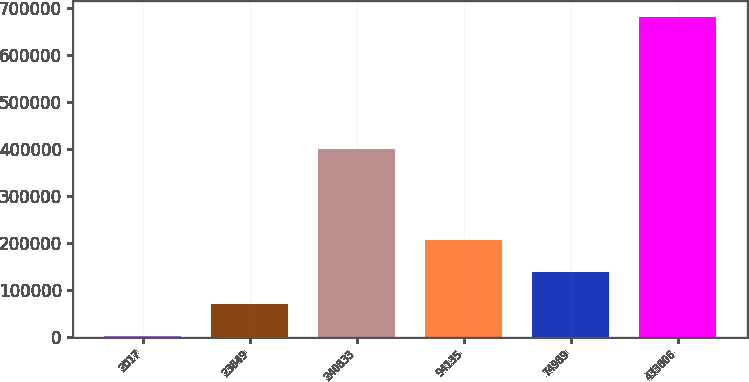Convert chart to OTSL. <chart><loc_0><loc_0><loc_500><loc_500><bar_chart><fcel>2017<fcel>23849<fcel>240833<fcel>94135<fcel>74989<fcel>433806<nl><fcel>2015<fcel>70025.3<fcel>401537<fcel>206046<fcel>138036<fcel>682118<nl></chart> 